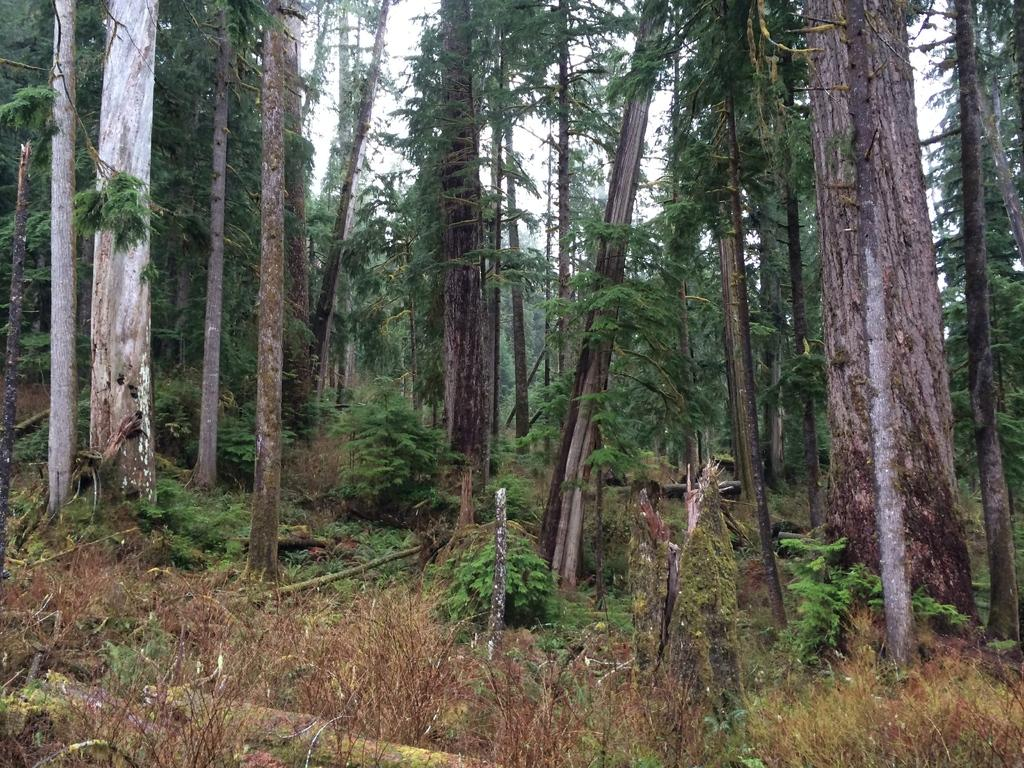What type of vegetation can be seen in the image? There are many trees and plants on the ground in the image. What else can be found on the ground in the image? There are logs on the ground. What is visible in the background of the image? The sky is visible in the background of the image. What type of wine is being served in the image? There is no wine present in the image; it features trees, plants, logs, and the sky. How many knots can be seen in the image? There are no knots visible in the image. 